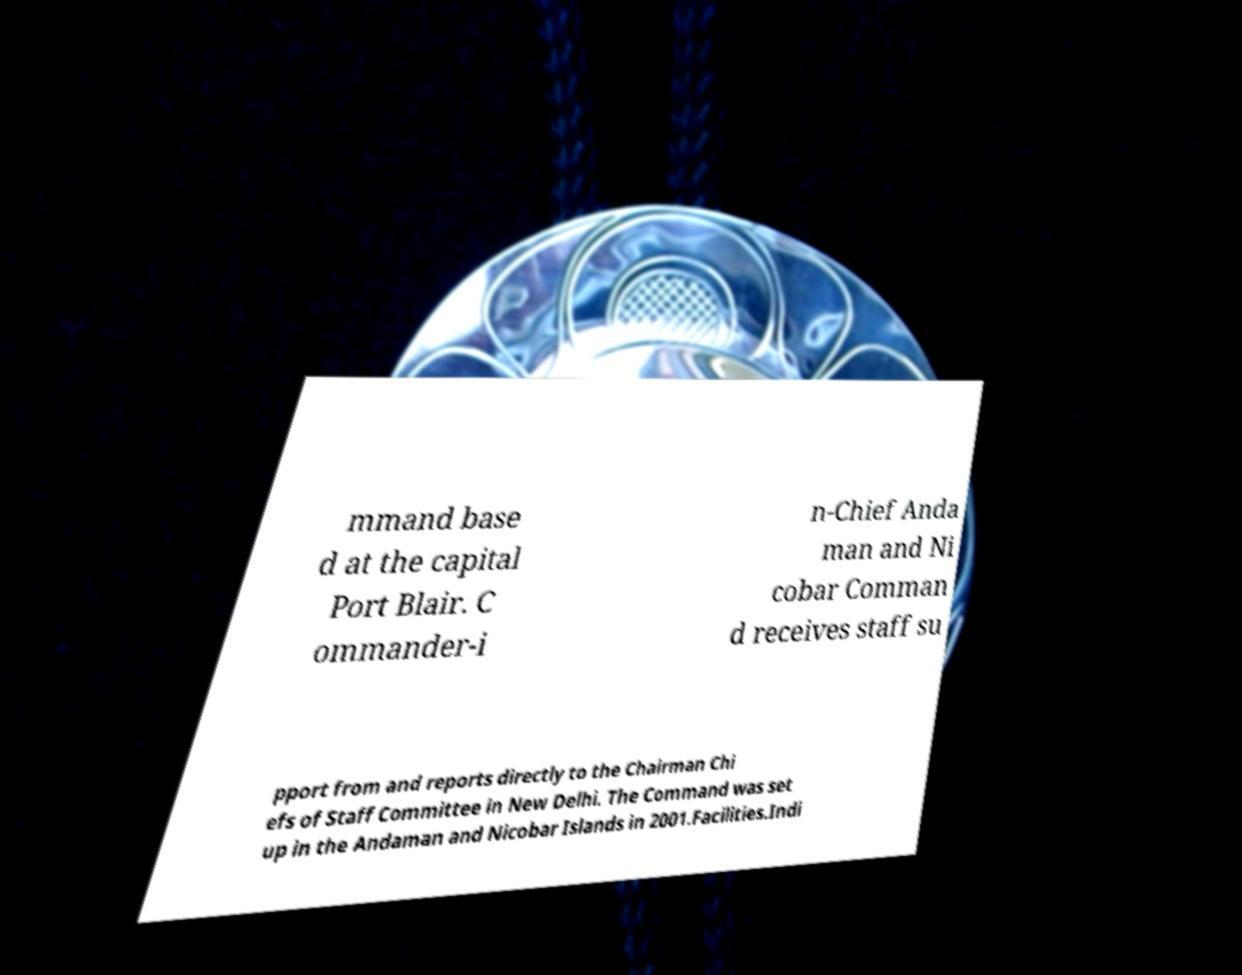Please read and relay the text visible in this image. What does it say? mmand base d at the capital Port Blair. C ommander-i n-Chief Anda man and Ni cobar Comman d receives staff su pport from and reports directly to the Chairman Chi efs of Staff Committee in New Delhi. The Command was set up in the Andaman and Nicobar Islands in 2001.Facilities.Indi 